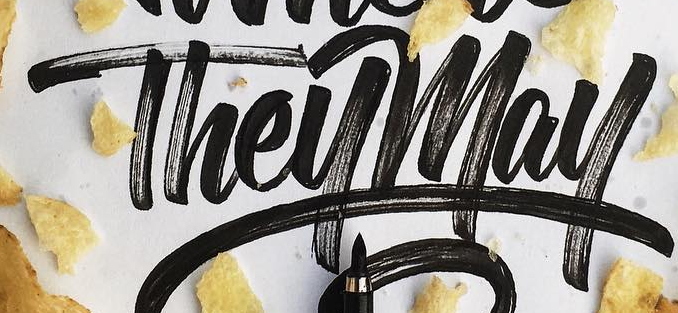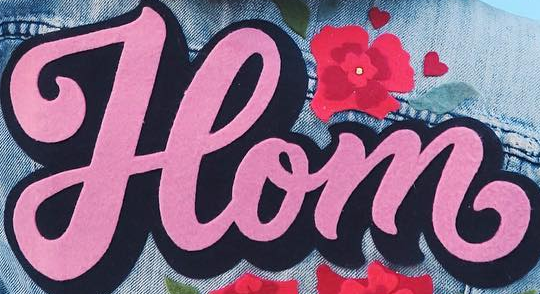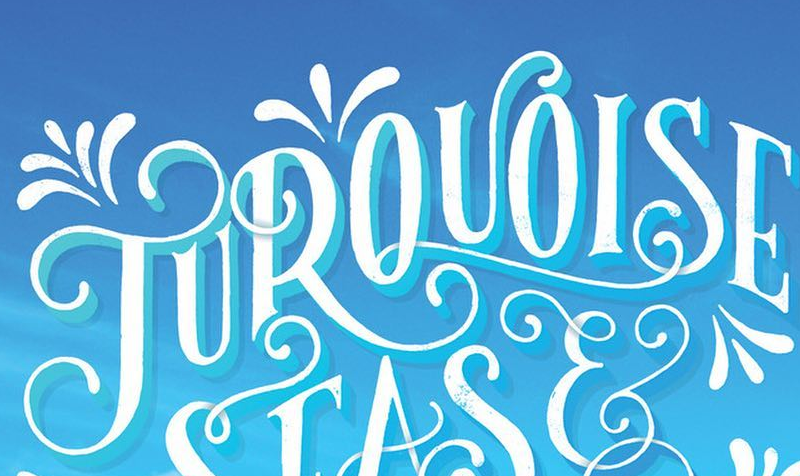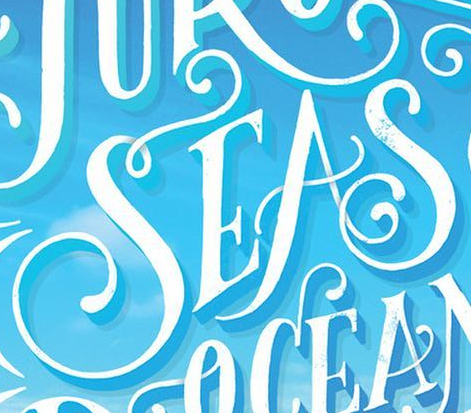What words can you see in these images in sequence, separated by a semicolon? Theymay; Hom; TUROUOISE; SEAS 